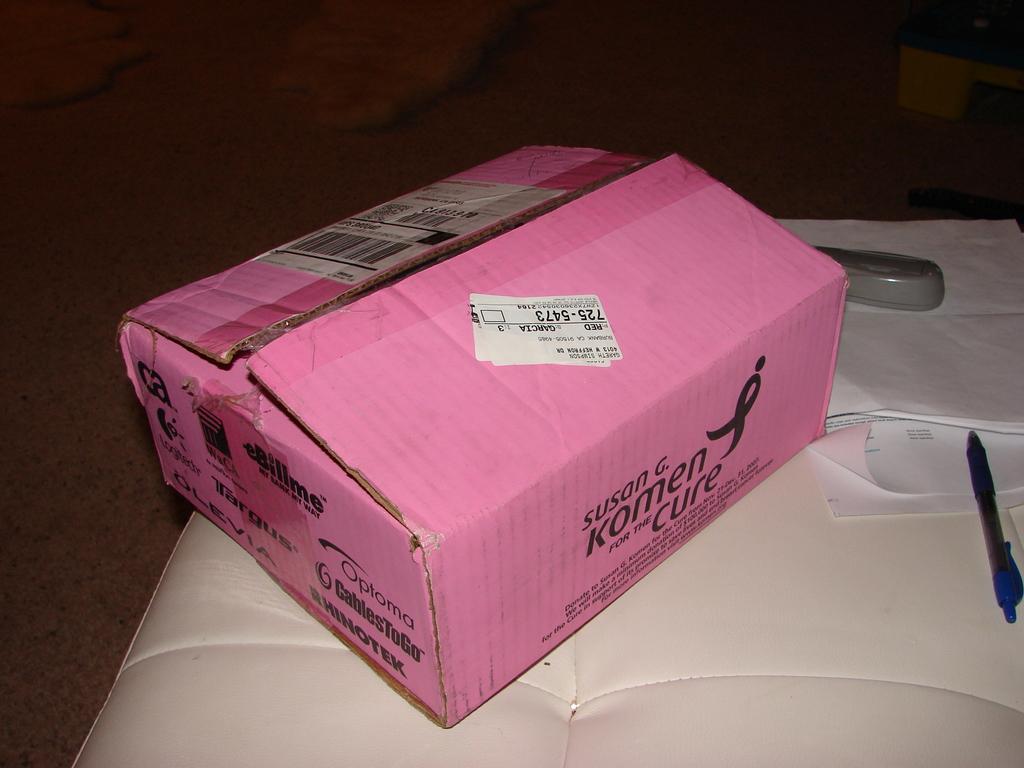Where is the box from?
Your response must be concise. Susan g komen. 